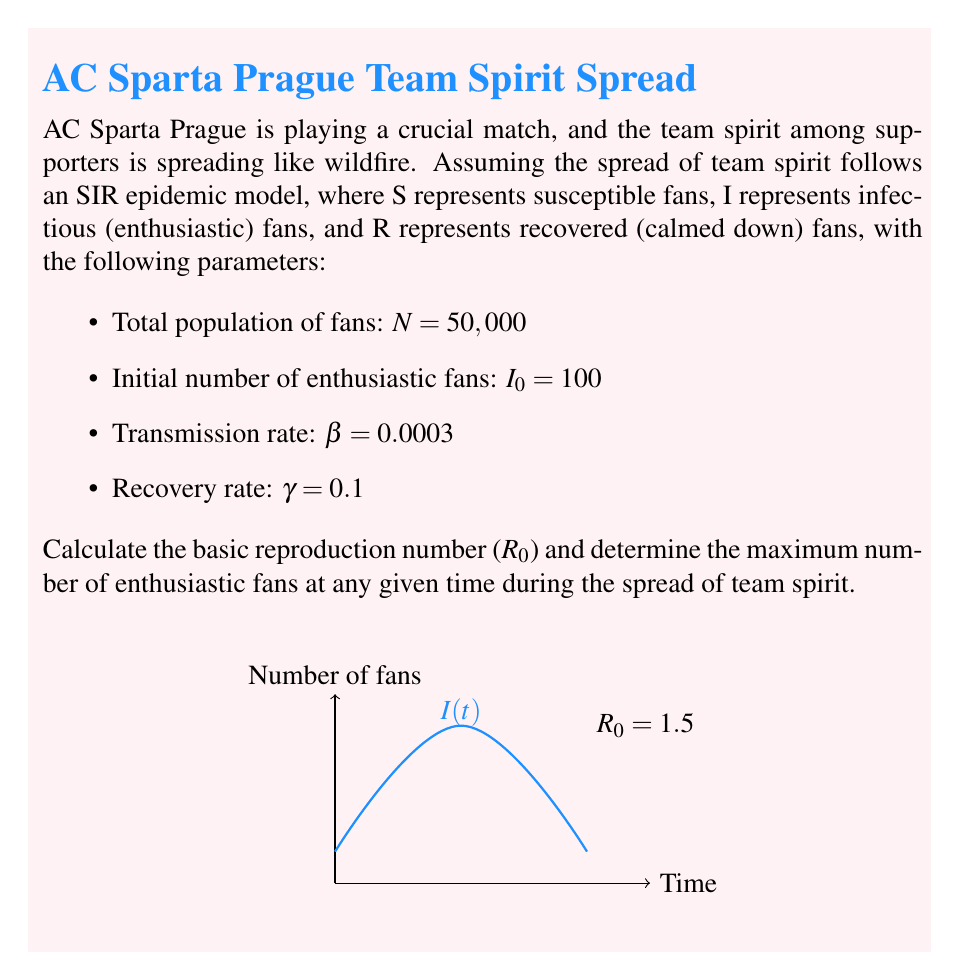What is the answer to this math problem? To solve this problem, we'll follow these steps:

1. Calculate the basic reproduction number ($R_0$):
   $R_0 = \frac{\beta N}{\gamma}$
   
   Where:
   $\beta$ = transmission rate
   $N$ = total population
   $\gamma$ = recovery rate

   $R_0 = \frac{0.0003 \times 50,000}{0.1} = 150$

2. To find the maximum number of enthusiastic fans, we need to use the formula:

   $I_{max} = N \left(1 - \frac{1 + \ln R_0}{R_0}\right)$

3. Substitute the values:

   $I_{max} = 50,000 \left(1 - \frac{1 + \ln 150}{150}\right)$

4. Calculate:
   $\ln 150 \approx 5.0106$
   
   $I_{max} = 50,000 \left(1 - \frac{1 + 5.0106}{150}\right)$
   
   $I_{max} = 50,000 \left(1 - \frac{6.0106}{150}\right)$
   
   $I_{max} = 50,000 (1 - 0.0401) = 50,000 \times 0.9599$
   
   $I_{max} = 47,995$

Therefore, the maximum number of enthusiastic fans at any given time during the spread of team spirit is approximately 47,995.
Answer: $R_0 = 150$; $I_{max} \approx 47,995$ fans 